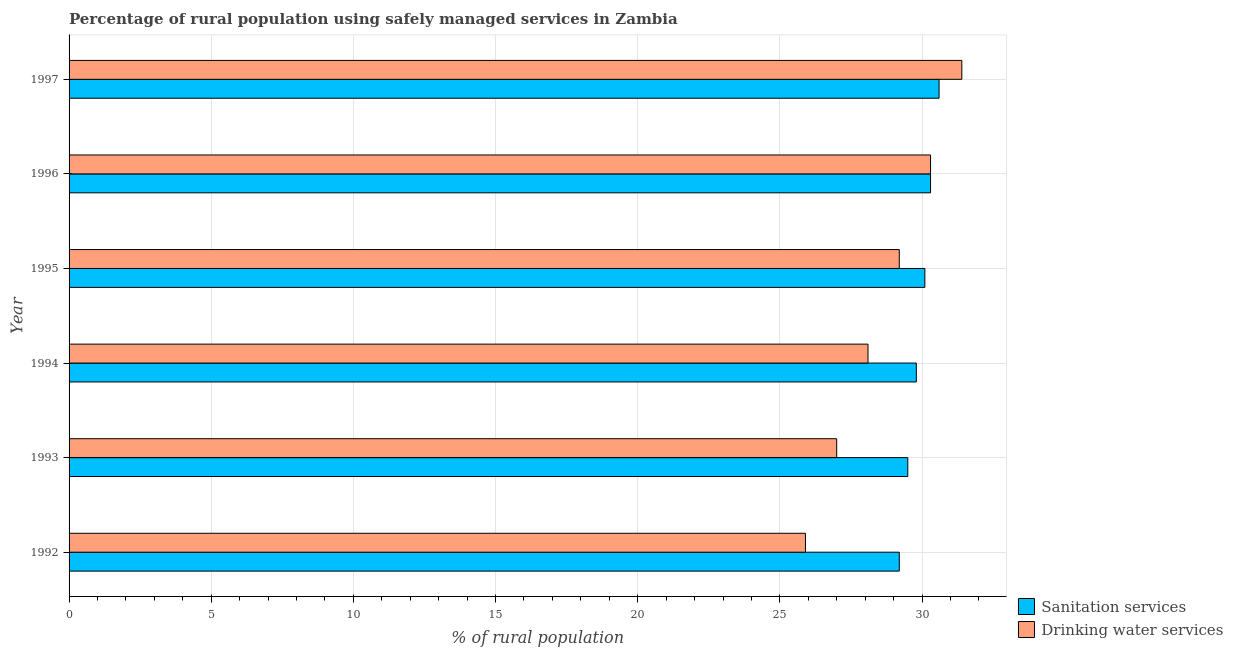How many different coloured bars are there?
Your response must be concise. 2. Are the number of bars per tick equal to the number of legend labels?
Keep it short and to the point. Yes. Are the number of bars on each tick of the Y-axis equal?
Make the answer very short. Yes. How many bars are there on the 2nd tick from the bottom?
Ensure brevity in your answer.  2. In how many cases, is the number of bars for a given year not equal to the number of legend labels?
Offer a terse response. 0. What is the percentage of rural population who used drinking water services in 1996?
Your response must be concise. 30.3. Across all years, what is the maximum percentage of rural population who used sanitation services?
Offer a terse response. 30.6. Across all years, what is the minimum percentage of rural population who used drinking water services?
Keep it short and to the point. 25.9. In which year was the percentage of rural population who used drinking water services maximum?
Give a very brief answer. 1997. What is the total percentage of rural population who used drinking water services in the graph?
Make the answer very short. 171.9. What is the difference between the percentage of rural population who used drinking water services in 1995 and that in 1996?
Keep it short and to the point. -1.1. What is the difference between the percentage of rural population who used drinking water services in 1993 and the percentage of rural population who used sanitation services in 1995?
Offer a terse response. -3.1. What is the average percentage of rural population who used sanitation services per year?
Keep it short and to the point. 29.92. In the year 1995, what is the difference between the percentage of rural population who used drinking water services and percentage of rural population who used sanitation services?
Offer a very short reply. -0.9. In how many years, is the percentage of rural population who used sanitation services greater than 14 %?
Ensure brevity in your answer.  6. What is the ratio of the percentage of rural population who used drinking water services in 1993 to that in 1995?
Your response must be concise. 0.93. Is the difference between the percentage of rural population who used sanitation services in 1993 and 1994 greater than the difference between the percentage of rural population who used drinking water services in 1993 and 1994?
Ensure brevity in your answer.  Yes. What is the difference between the highest and the second highest percentage of rural population who used sanitation services?
Offer a terse response. 0.3. What is the difference between the highest and the lowest percentage of rural population who used drinking water services?
Your answer should be very brief. 5.5. In how many years, is the percentage of rural population who used drinking water services greater than the average percentage of rural population who used drinking water services taken over all years?
Your answer should be compact. 3. Is the sum of the percentage of rural population who used drinking water services in 1993 and 1995 greater than the maximum percentage of rural population who used sanitation services across all years?
Ensure brevity in your answer.  Yes. What does the 1st bar from the top in 1997 represents?
Your answer should be very brief. Drinking water services. What does the 2nd bar from the bottom in 1994 represents?
Your response must be concise. Drinking water services. How many bars are there?
Offer a terse response. 12. How many legend labels are there?
Ensure brevity in your answer.  2. What is the title of the graph?
Provide a short and direct response. Percentage of rural population using safely managed services in Zambia. What is the label or title of the X-axis?
Make the answer very short. % of rural population. What is the % of rural population of Sanitation services in 1992?
Give a very brief answer. 29.2. What is the % of rural population of Drinking water services in 1992?
Keep it short and to the point. 25.9. What is the % of rural population in Sanitation services in 1993?
Offer a terse response. 29.5. What is the % of rural population in Drinking water services in 1993?
Your response must be concise. 27. What is the % of rural population in Sanitation services in 1994?
Provide a short and direct response. 29.8. What is the % of rural population of Drinking water services in 1994?
Make the answer very short. 28.1. What is the % of rural population of Sanitation services in 1995?
Offer a terse response. 30.1. What is the % of rural population of Drinking water services in 1995?
Offer a very short reply. 29.2. What is the % of rural population in Sanitation services in 1996?
Your answer should be compact. 30.3. What is the % of rural population of Drinking water services in 1996?
Offer a very short reply. 30.3. What is the % of rural population of Sanitation services in 1997?
Your answer should be compact. 30.6. What is the % of rural population in Drinking water services in 1997?
Give a very brief answer. 31.4. Across all years, what is the maximum % of rural population of Sanitation services?
Provide a short and direct response. 30.6. Across all years, what is the maximum % of rural population of Drinking water services?
Offer a terse response. 31.4. Across all years, what is the minimum % of rural population of Sanitation services?
Provide a short and direct response. 29.2. Across all years, what is the minimum % of rural population in Drinking water services?
Provide a short and direct response. 25.9. What is the total % of rural population in Sanitation services in the graph?
Ensure brevity in your answer.  179.5. What is the total % of rural population in Drinking water services in the graph?
Make the answer very short. 171.9. What is the difference between the % of rural population of Sanitation services in 1992 and that in 1993?
Your response must be concise. -0.3. What is the difference between the % of rural population of Sanitation services in 1992 and that in 1994?
Your answer should be compact. -0.6. What is the difference between the % of rural population in Drinking water services in 1992 and that in 1994?
Your response must be concise. -2.2. What is the difference between the % of rural population in Sanitation services in 1992 and that in 1995?
Your answer should be compact. -0.9. What is the difference between the % of rural population of Sanitation services in 1992 and that in 1996?
Ensure brevity in your answer.  -1.1. What is the difference between the % of rural population in Sanitation services in 1992 and that in 1997?
Make the answer very short. -1.4. What is the difference between the % of rural population in Sanitation services in 1993 and that in 1995?
Give a very brief answer. -0.6. What is the difference between the % of rural population in Drinking water services in 1993 and that in 1996?
Your response must be concise. -3.3. What is the difference between the % of rural population of Drinking water services in 1993 and that in 1997?
Ensure brevity in your answer.  -4.4. What is the difference between the % of rural population in Sanitation services in 1994 and that in 1996?
Provide a succinct answer. -0.5. What is the difference between the % of rural population of Drinking water services in 1994 and that in 1997?
Your answer should be compact. -3.3. What is the difference between the % of rural population in Sanitation services in 1995 and that in 1996?
Your response must be concise. -0.2. What is the difference between the % of rural population of Sanitation services in 1995 and that in 1997?
Offer a terse response. -0.5. What is the difference between the % of rural population of Sanitation services in 1996 and that in 1997?
Keep it short and to the point. -0.3. What is the difference between the % of rural population of Drinking water services in 1996 and that in 1997?
Provide a short and direct response. -1.1. What is the difference between the % of rural population in Sanitation services in 1992 and the % of rural population in Drinking water services in 1994?
Your response must be concise. 1.1. What is the difference between the % of rural population of Sanitation services in 1992 and the % of rural population of Drinking water services in 1995?
Make the answer very short. 0. What is the difference between the % of rural population in Sanitation services in 1992 and the % of rural population in Drinking water services in 1996?
Offer a very short reply. -1.1. What is the difference between the % of rural population of Sanitation services in 1992 and the % of rural population of Drinking water services in 1997?
Keep it short and to the point. -2.2. What is the difference between the % of rural population of Sanitation services in 1993 and the % of rural population of Drinking water services in 1994?
Your response must be concise. 1.4. What is the difference between the % of rural population in Sanitation services in 1993 and the % of rural population in Drinking water services in 1995?
Give a very brief answer. 0.3. What is the difference between the % of rural population in Sanitation services in 1994 and the % of rural population in Drinking water services in 1996?
Offer a terse response. -0.5. What is the difference between the % of rural population in Sanitation services in 1996 and the % of rural population in Drinking water services in 1997?
Give a very brief answer. -1.1. What is the average % of rural population of Sanitation services per year?
Ensure brevity in your answer.  29.92. What is the average % of rural population in Drinking water services per year?
Give a very brief answer. 28.65. In the year 1992, what is the difference between the % of rural population in Sanitation services and % of rural population in Drinking water services?
Keep it short and to the point. 3.3. In the year 1993, what is the difference between the % of rural population of Sanitation services and % of rural population of Drinking water services?
Keep it short and to the point. 2.5. In the year 1994, what is the difference between the % of rural population of Sanitation services and % of rural population of Drinking water services?
Ensure brevity in your answer.  1.7. In the year 1997, what is the difference between the % of rural population of Sanitation services and % of rural population of Drinking water services?
Your response must be concise. -0.8. What is the ratio of the % of rural population of Drinking water services in 1992 to that in 1993?
Ensure brevity in your answer.  0.96. What is the ratio of the % of rural population in Sanitation services in 1992 to that in 1994?
Keep it short and to the point. 0.98. What is the ratio of the % of rural population in Drinking water services in 1992 to that in 1994?
Your answer should be very brief. 0.92. What is the ratio of the % of rural population in Sanitation services in 1992 to that in 1995?
Keep it short and to the point. 0.97. What is the ratio of the % of rural population in Drinking water services in 1992 to that in 1995?
Give a very brief answer. 0.89. What is the ratio of the % of rural population in Sanitation services in 1992 to that in 1996?
Give a very brief answer. 0.96. What is the ratio of the % of rural population in Drinking water services in 1992 to that in 1996?
Provide a short and direct response. 0.85. What is the ratio of the % of rural population in Sanitation services in 1992 to that in 1997?
Offer a very short reply. 0.95. What is the ratio of the % of rural population of Drinking water services in 1992 to that in 1997?
Ensure brevity in your answer.  0.82. What is the ratio of the % of rural population in Drinking water services in 1993 to that in 1994?
Provide a short and direct response. 0.96. What is the ratio of the % of rural population of Sanitation services in 1993 to that in 1995?
Provide a succinct answer. 0.98. What is the ratio of the % of rural population of Drinking water services in 1993 to that in 1995?
Provide a short and direct response. 0.92. What is the ratio of the % of rural population in Sanitation services in 1993 to that in 1996?
Ensure brevity in your answer.  0.97. What is the ratio of the % of rural population of Drinking water services in 1993 to that in 1996?
Make the answer very short. 0.89. What is the ratio of the % of rural population in Sanitation services in 1993 to that in 1997?
Offer a terse response. 0.96. What is the ratio of the % of rural population in Drinking water services in 1993 to that in 1997?
Give a very brief answer. 0.86. What is the ratio of the % of rural population in Sanitation services in 1994 to that in 1995?
Provide a short and direct response. 0.99. What is the ratio of the % of rural population of Drinking water services in 1994 to that in 1995?
Ensure brevity in your answer.  0.96. What is the ratio of the % of rural population in Sanitation services in 1994 to that in 1996?
Ensure brevity in your answer.  0.98. What is the ratio of the % of rural population in Drinking water services in 1994 to that in 1996?
Your answer should be compact. 0.93. What is the ratio of the % of rural population of Sanitation services in 1994 to that in 1997?
Offer a terse response. 0.97. What is the ratio of the % of rural population in Drinking water services in 1994 to that in 1997?
Ensure brevity in your answer.  0.89. What is the ratio of the % of rural population of Drinking water services in 1995 to that in 1996?
Provide a succinct answer. 0.96. What is the ratio of the % of rural population of Sanitation services in 1995 to that in 1997?
Provide a succinct answer. 0.98. What is the ratio of the % of rural population of Drinking water services in 1995 to that in 1997?
Provide a short and direct response. 0.93. What is the ratio of the % of rural population of Sanitation services in 1996 to that in 1997?
Keep it short and to the point. 0.99. What is the difference between the highest and the second highest % of rural population of Sanitation services?
Offer a terse response. 0.3. What is the difference between the highest and the second highest % of rural population of Drinking water services?
Keep it short and to the point. 1.1. 